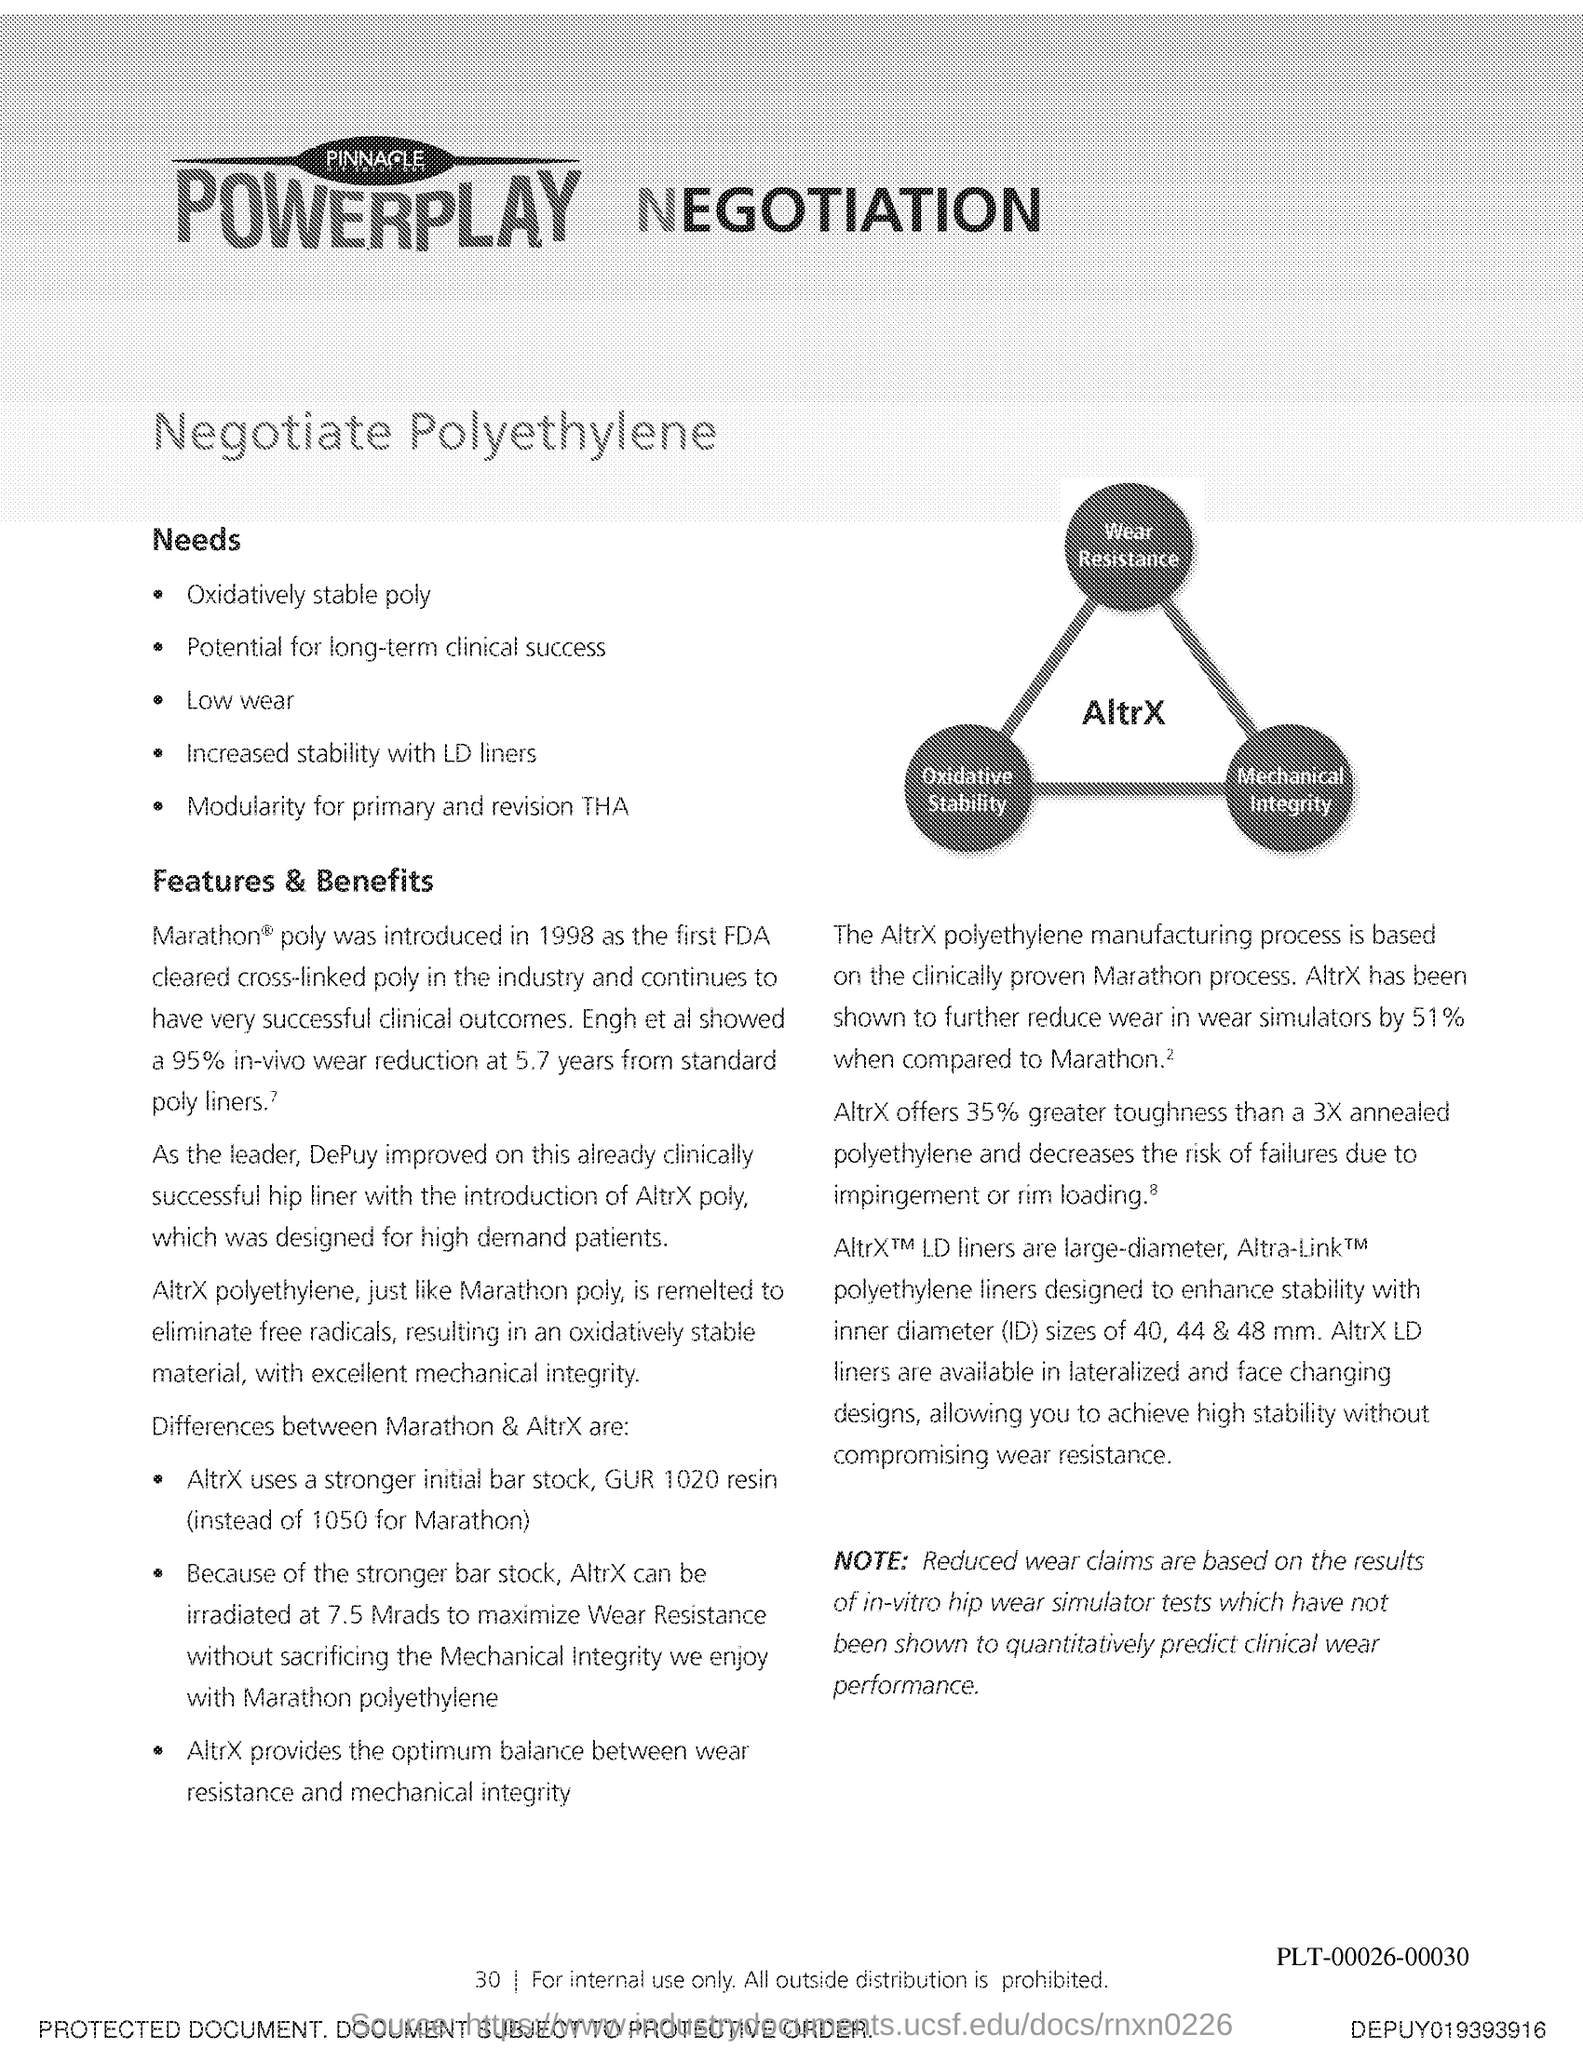What is the Page Number?
Make the answer very short. 30. 